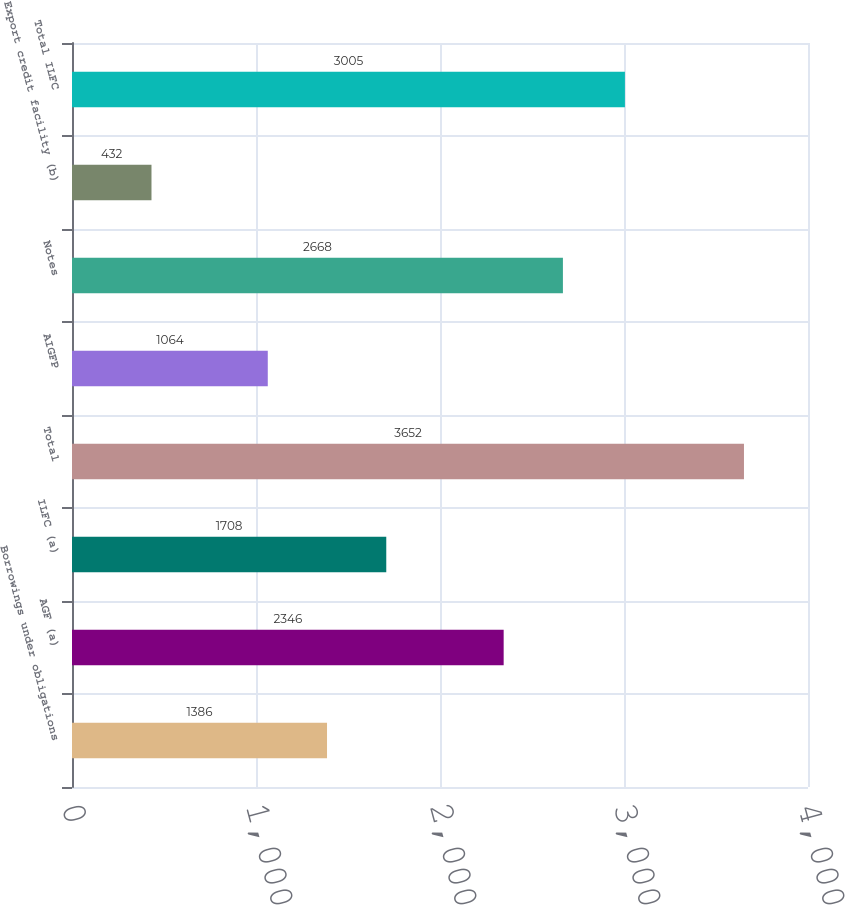Convert chart to OTSL. <chart><loc_0><loc_0><loc_500><loc_500><bar_chart><fcel>Borrowings under obligations<fcel>AGF (a)<fcel>ILFC (a)<fcel>Total<fcel>AIGFP<fcel>Notes<fcel>Export credit facility (b)<fcel>Total ILFC<nl><fcel>1386<fcel>2346<fcel>1708<fcel>3652<fcel>1064<fcel>2668<fcel>432<fcel>3005<nl></chart> 